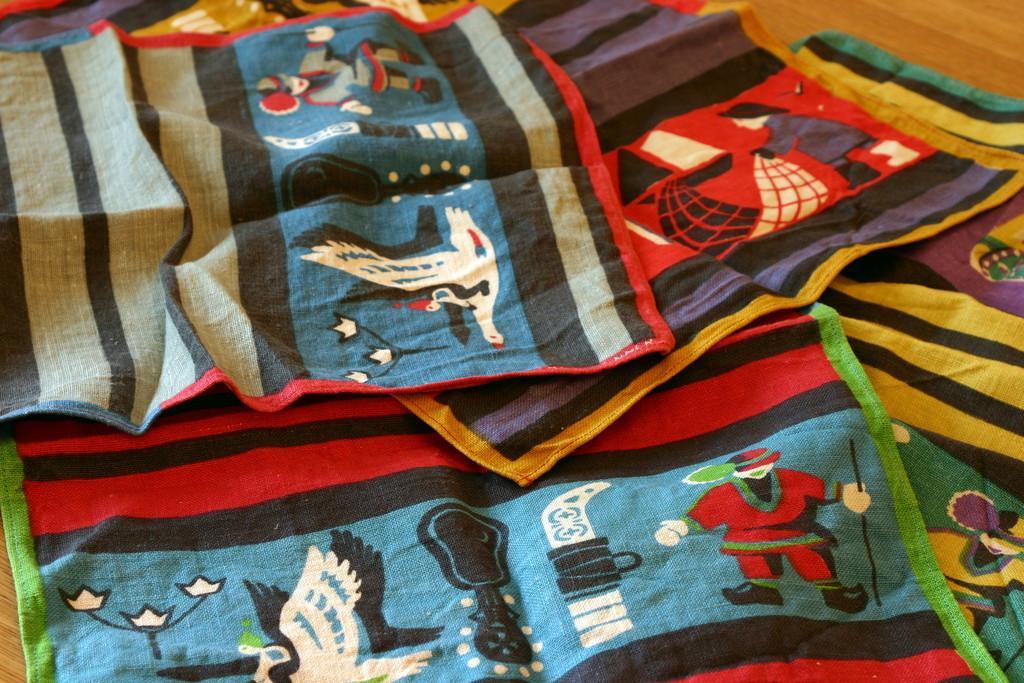Please provide a concise description of this image. In this image we can see kerchiefs with designs. And these are on a wooden surface. 